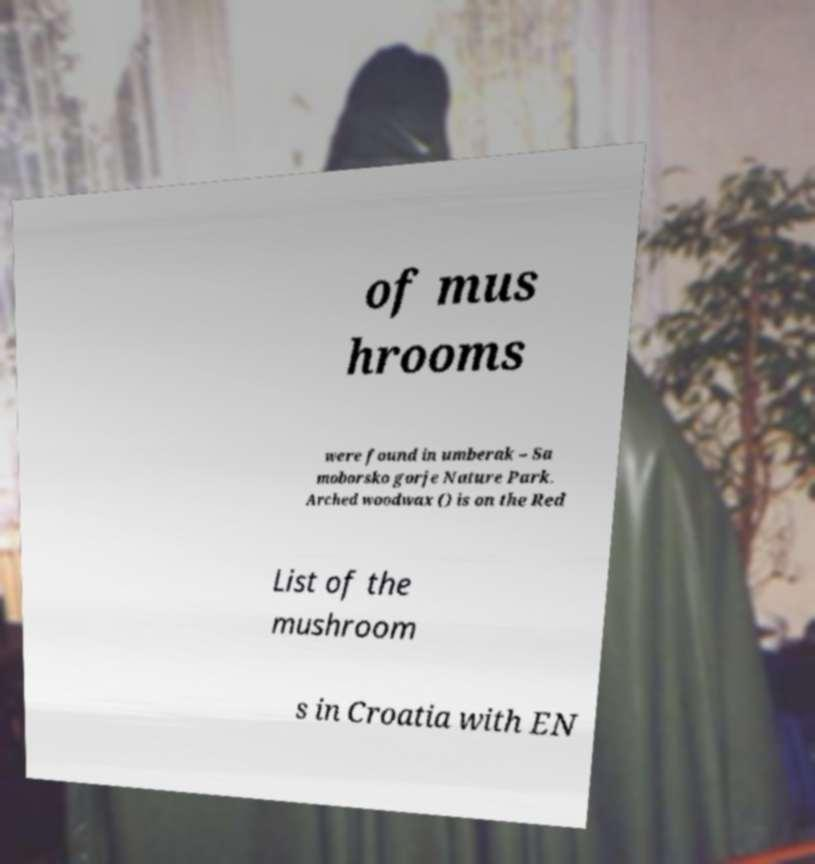For documentation purposes, I need the text within this image transcribed. Could you provide that? of mus hrooms were found in umberak – Sa moborsko gorje Nature Park. Arched woodwax () is on the Red List of the mushroom s in Croatia with EN 